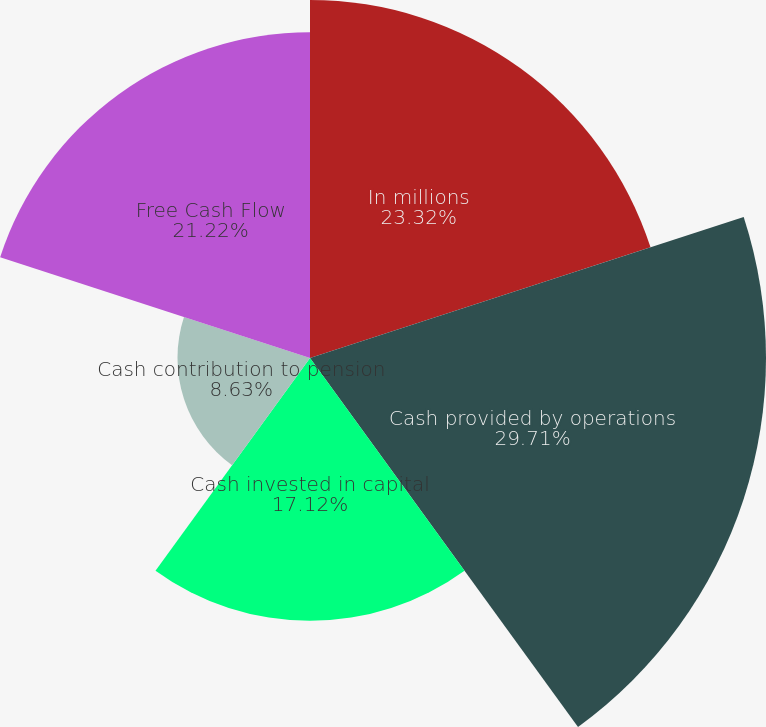Convert chart. <chart><loc_0><loc_0><loc_500><loc_500><pie_chart><fcel>In millions<fcel>Cash provided by operations<fcel>Cash invested in capital<fcel>Cash contribution to pension<fcel>Free Cash Flow<nl><fcel>23.32%<fcel>29.7%<fcel>17.12%<fcel>8.63%<fcel>21.22%<nl></chart> 